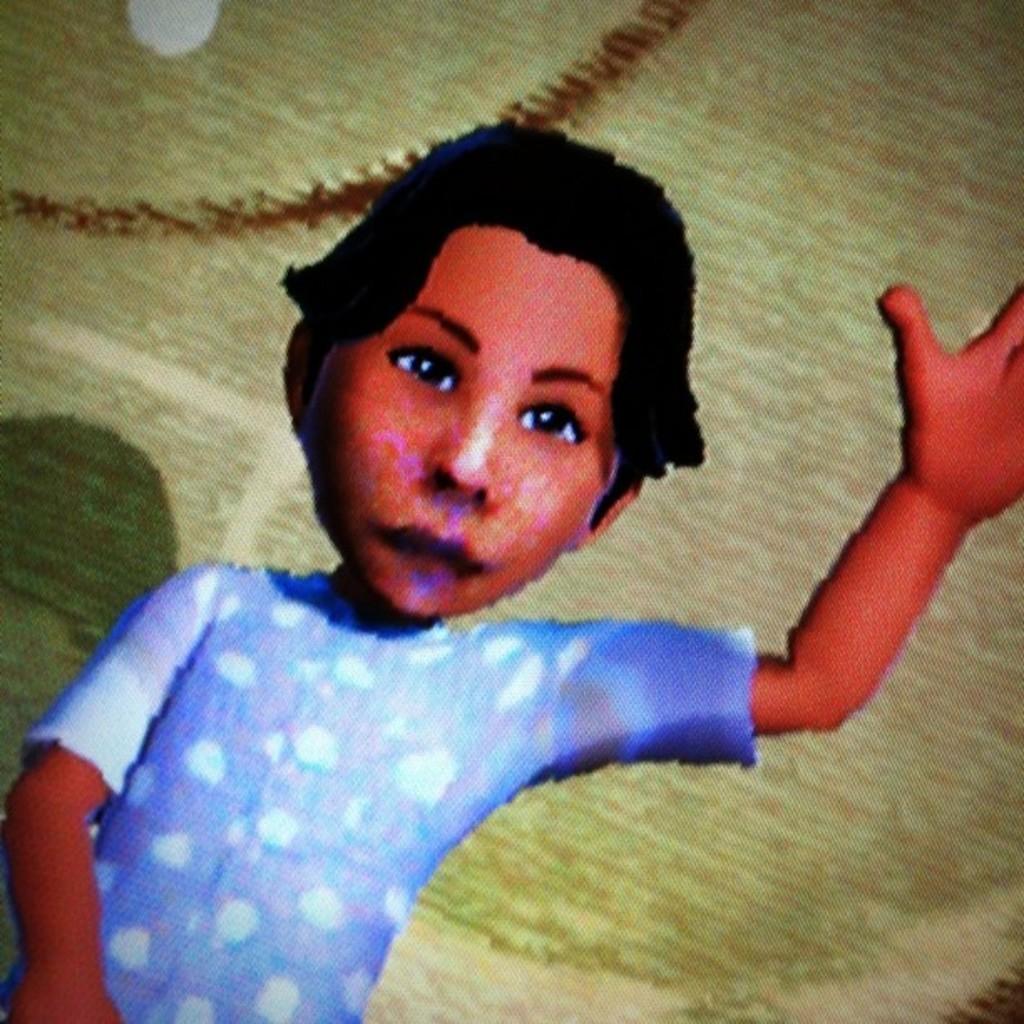Can you describe this image briefly? In the foreground of this image, there is an animated boy raising one hand up in the air and the unclear background. 